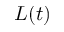<formula> <loc_0><loc_0><loc_500><loc_500>L ( t )</formula> 